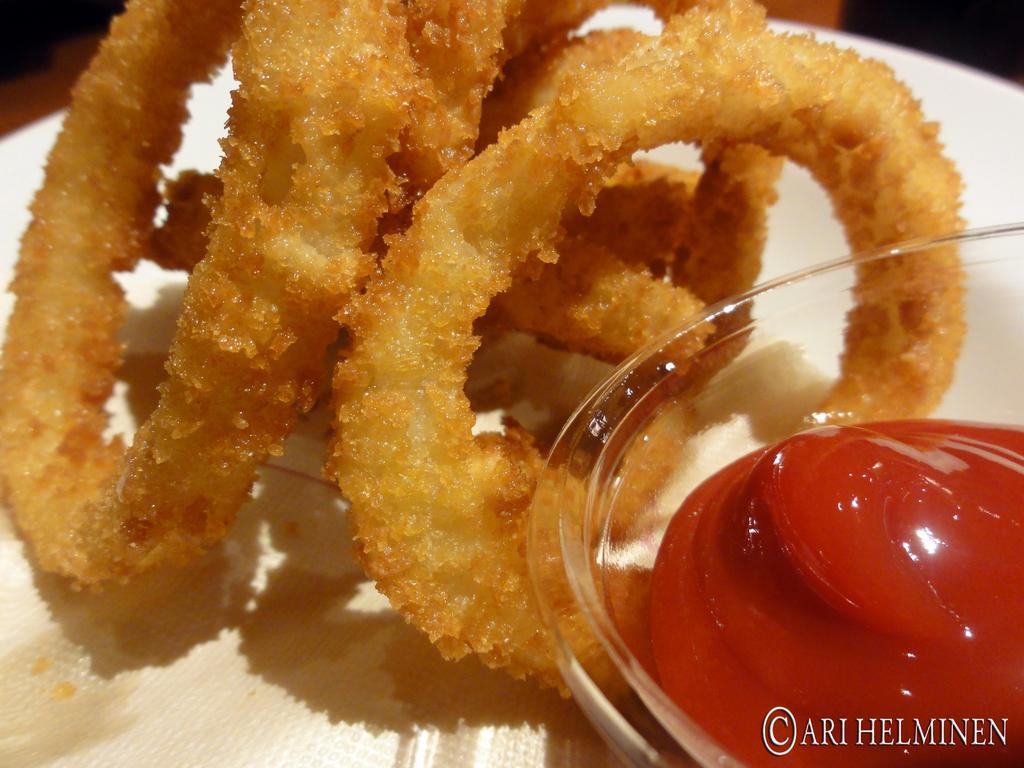Describe this image in one or two sentences. In this image I can see the food and sauce in the glass bowl. They are on the white color plate. Food is in brown color. 